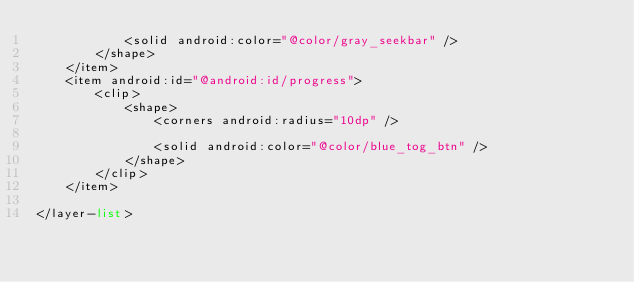Convert code to text. <code><loc_0><loc_0><loc_500><loc_500><_XML_>            <solid android:color="@color/gray_seekbar" />
        </shape>
    </item>
    <item android:id="@android:id/progress">
        <clip>
            <shape>
                <corners android:radius="10dp" />

                <solid android:color="@color/blue_tog_btn" />
            </shape>
        </clip>
    </item>

</layer-list></code> 